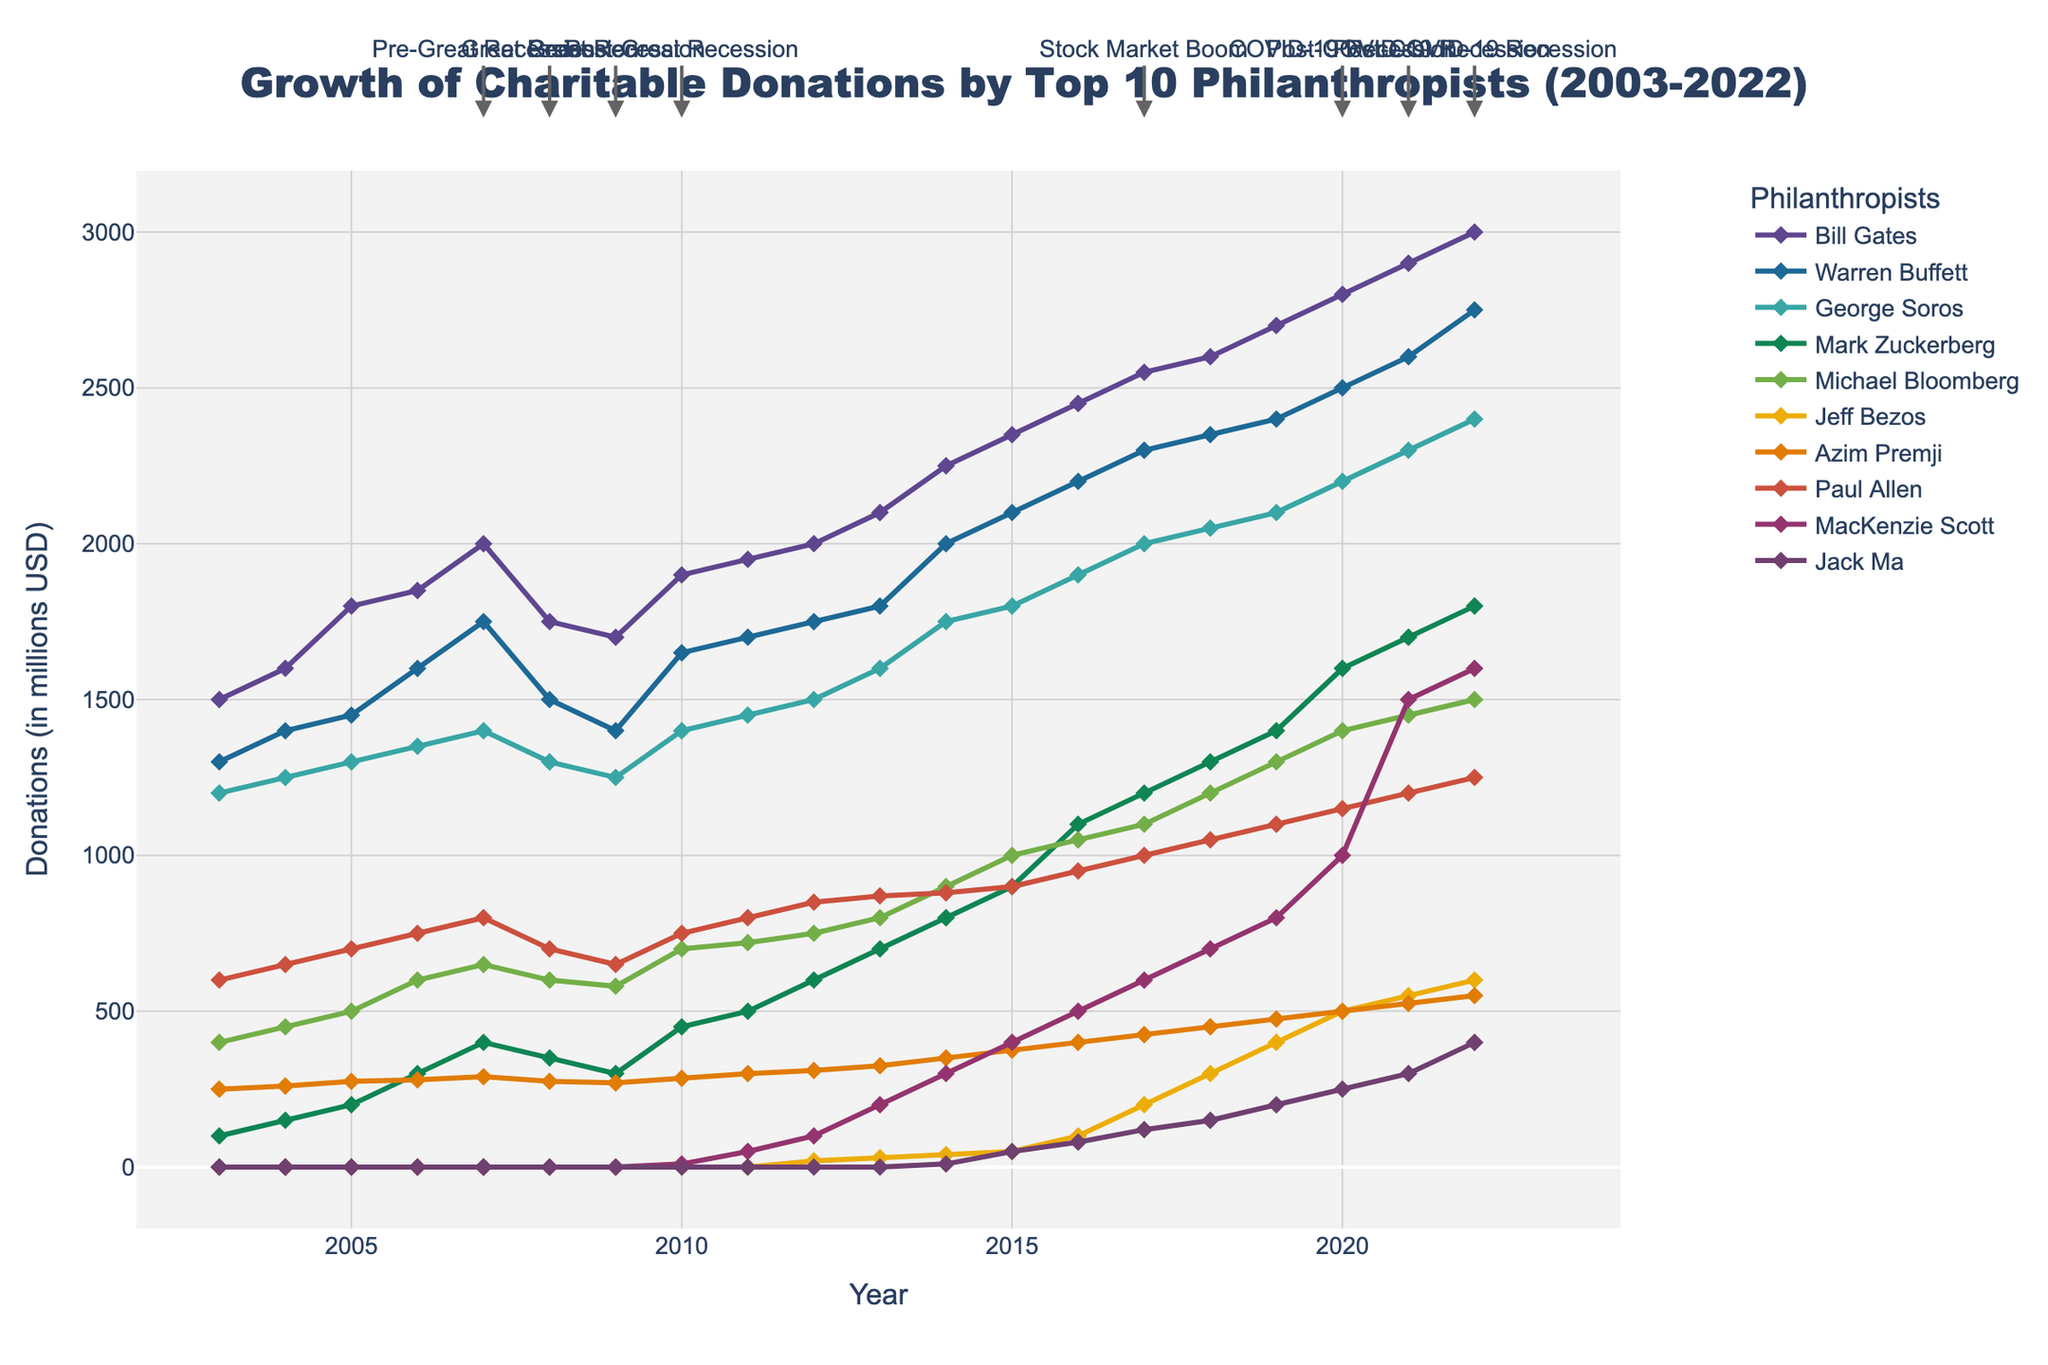What is the title of the figure? The title of the figure is displayed at the top, and it reads "Growth of Charitable Donations by Top 10 Philanthropists (2003-2022)"
Answer: Growth of Charitable Donations by Top 10 Philanthropists (2003-2022) Who has the highest donation amount in 2022? By looking at the end of the time series plot for the year 2022, we can see that Bill Gates has the highest donation amount as his line is the highest on the vertical axis.
Answer: Bill Gates During the Great Recession, how did Warren Buffett's donations change? To find how Warren Buffett's donations changed during the Great Recession, we look at the years 2008-2009: his donations decreased from 1500 million USD in 2008 to 1400 million USD in 2009.
Answer: Decreased Which philanthropist showed a sudden increase in donations around the Post-COVID-19 Recession period? By examining the section of the plot around 2020-2022, we see that MacKenzie Scott’s donations show a sudden increase, as indicated by the steep rising curve for her line.
Answer: MacKenzie Scott How many major economic events are highlighted in the plot? By counting the annotated major economic events scattered throughout the plot, we observe that there are 5 major economic events highlighted.
Answer: 5 What is the general trend of donations for Mark Zuckerberg over the 20 years? Mark Zuckerberg's donations show a general upward trend, starting low in 2003 and gradually increasing to a higher value in 2022, indicated by the rising line on the plot.
Answer: Upward trend Compare the trends of donations by Jeff Bezos and Jack Ma. Jeff Bezos’ donation trend starts from almost zero and gradually increases over time, meanwhile Jack Ma's donations began later but also show a consistent increasing trend, though at a slower rate compared to Bezos’s.
Answer: Bezos' donations increase faster What was the effect of the Stock Market Boom on Bill Gates's donations? Checking the year marked as the Stock Market Boom in 2017, Bill Gates' donations increased from 2450 million USD in 2016 to 2550 million USD in 2017, reflecting growth during this period.
Answer: Increased Between 2003 and 2022, who showed the most consistent growth in donations? The most consistent growth can be identified by observing the smoothest upwards curve; Michael Bloomberg’s donations show a steady, consistent increase over the entire period.
Answer: Michael Bloomberg 